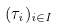Convert formula to latex. <formula><loc_0><loc_0><loc_500><loc_500>( \tau _ { i } ) _ { i \in I }</formula> 